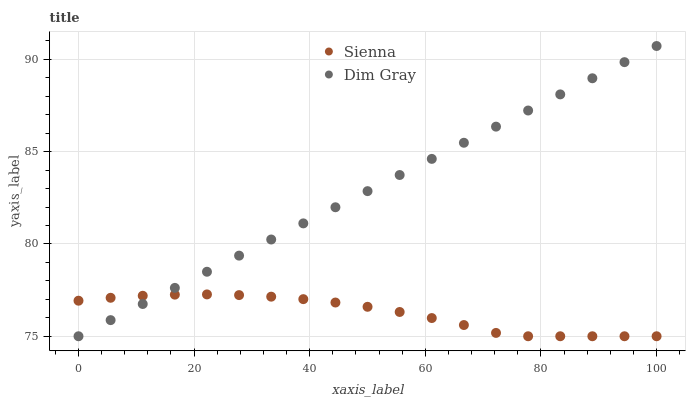Does Sienna have the minimum area under the curve?
Answer yes or no. Yes. Does Dim Gray have the maximum area under the curve?
Answer yes or no. Yes. Does Dim Gray have the minimum area under the curve?
Answer yes or no. No. Is Dim Gray the smoothest?
Answer yes or no. Yes. Is Sienna the roughest?
Answer yes or no. Yes. Is Dim Gray the roughest?
Answer yes or no. No. Does Sienna have the lowest value?
Answer yes or no. Yes. Does Dim Gray have the highest value?
Answer yes or no. Yes. Does Sienna intersect Dim Gray?
Answer yes or no. Yes. Is Sienna less than Dim Gray?
Answer yes or no. No. Is Sienna greater than Dim Gray?
Answer yes or no. No. 